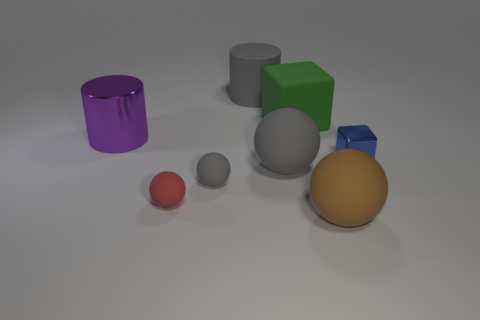There is a purple cylinder that is the same size as the green matte thing; what is its material?
Offer a terse response. Metal. What number of other things are made of the same material as the red sphere?
Make the answer very short. 5. Do the large gray matte object to the right of the big rubber cylinder and the object that is left of the small red matte sphere have the same shape?
Your response must be concise. No. How many other things are the same color as the large metal object?
Provide a short and direct response. 0. Is the block that is on the right side of the brown matte object made of the same material as the object that is behind the green block?
Offer a terse response. No. Is the number of small rubber objects left of the red rubber ball the same as the number of red rubber things that are on the right side of the blue thing?
Provide a succinct answer. Yes. What material is the gray object that is on the left side of the large gray rubber cylinder?
Offer a very short reply. Rubber. Is there any other thing that has the same size as the green thing?
Offer a terse response. Yes. Is the number of matte cylinders less than the number of brown matte cubes?
Keep it short and to the point. No. What is the shape of the object that is both to the right of the big block and in front of the small blue metallic thing?
Your answer should be very brief. Sphere. 